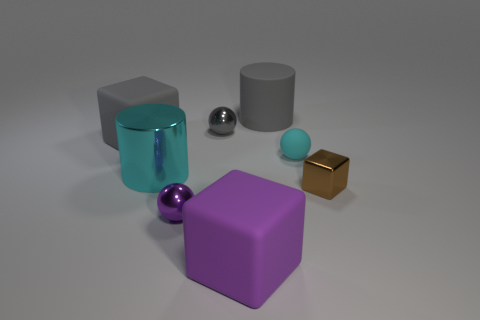Subtract all tiny matte balls. How many balls are left? 2 Add 2 small gray metal things. How many objects exist? 10 Subtract all purple blocks. How many blocks are left? 2 Subtract all cubes. How many objects are left? 5 Add 4 large cubes. How many large cubes are left? 6 Add 1 blue matte blocks. How many blue matte blocks exist? 1 Subtract 1 cyan balls. How many objects are left? 7 Subtract 2 balls. How many balls are left? 1 Subtract all yellow blocks. Subtract all purple cylinders. How many blocks are left? 3 Subtract all blue cylinders. How many cyan spheres are left? 1 